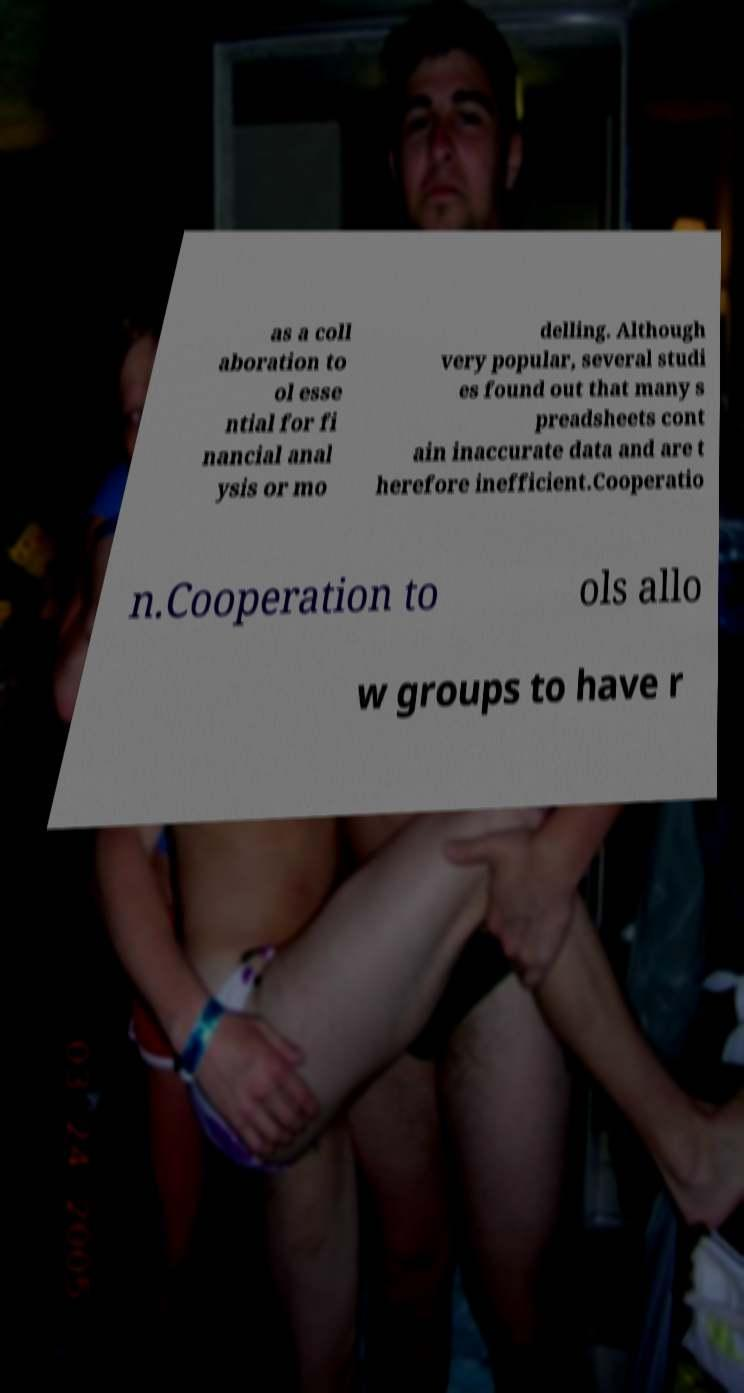Can you read and provide the text displayed in the image?This photo seems to have some interesting text. Can you extract and type it out for me? as a coll aboration to ol esse ntial for fi nancial anal ysis or mo delling. Although very popular, several studi es found out that many s preadsheets cont ain inaccurate data and are t herefore inefficient.Cooperatio n.Cooperation to ols allo w groups to have r 